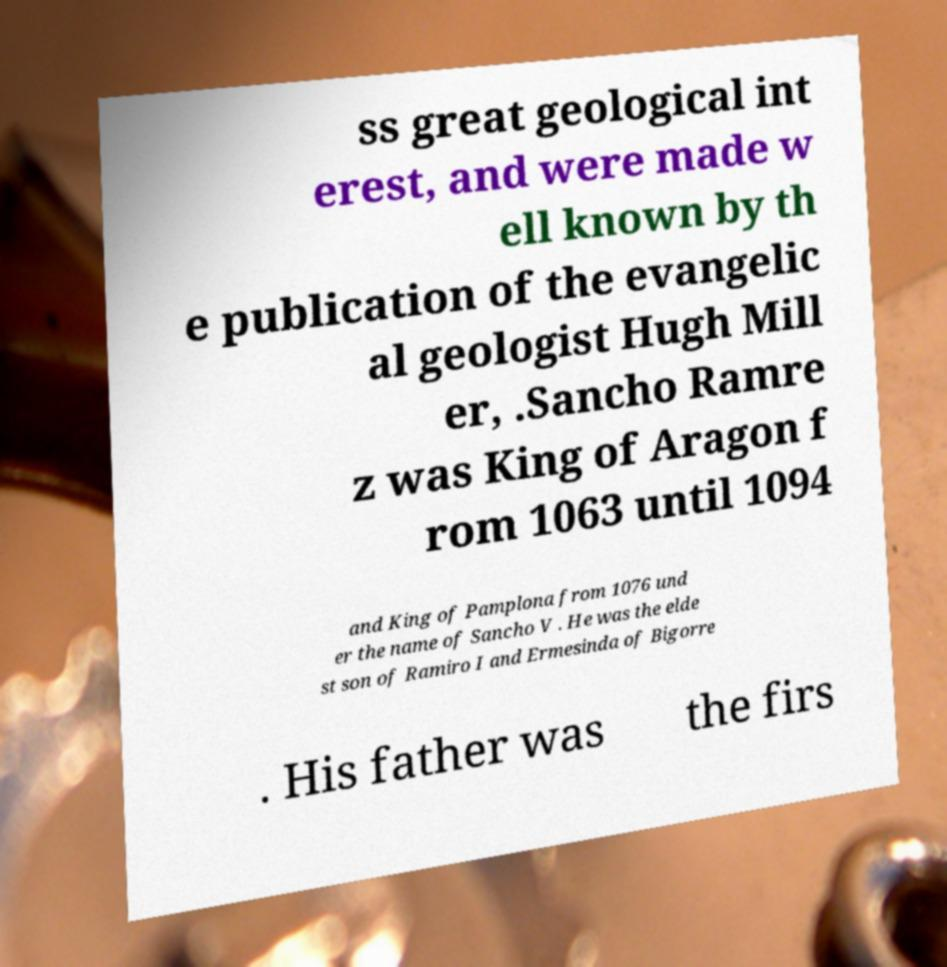For documentation purposes, I need the text within this image transcribed. Could you provide that? ss great geological int erest, and were made w ell known by th e publication of the evangelic al geologist Hugh Mill er, .Sancho Ramre z was King of Aragon f rom 1063 until 1094 and King of Pamplona from 1076 und er the name of Sancho V . He was the elde st son of Ramiro I and Ermesinda of Bigorre . His father was the firs 